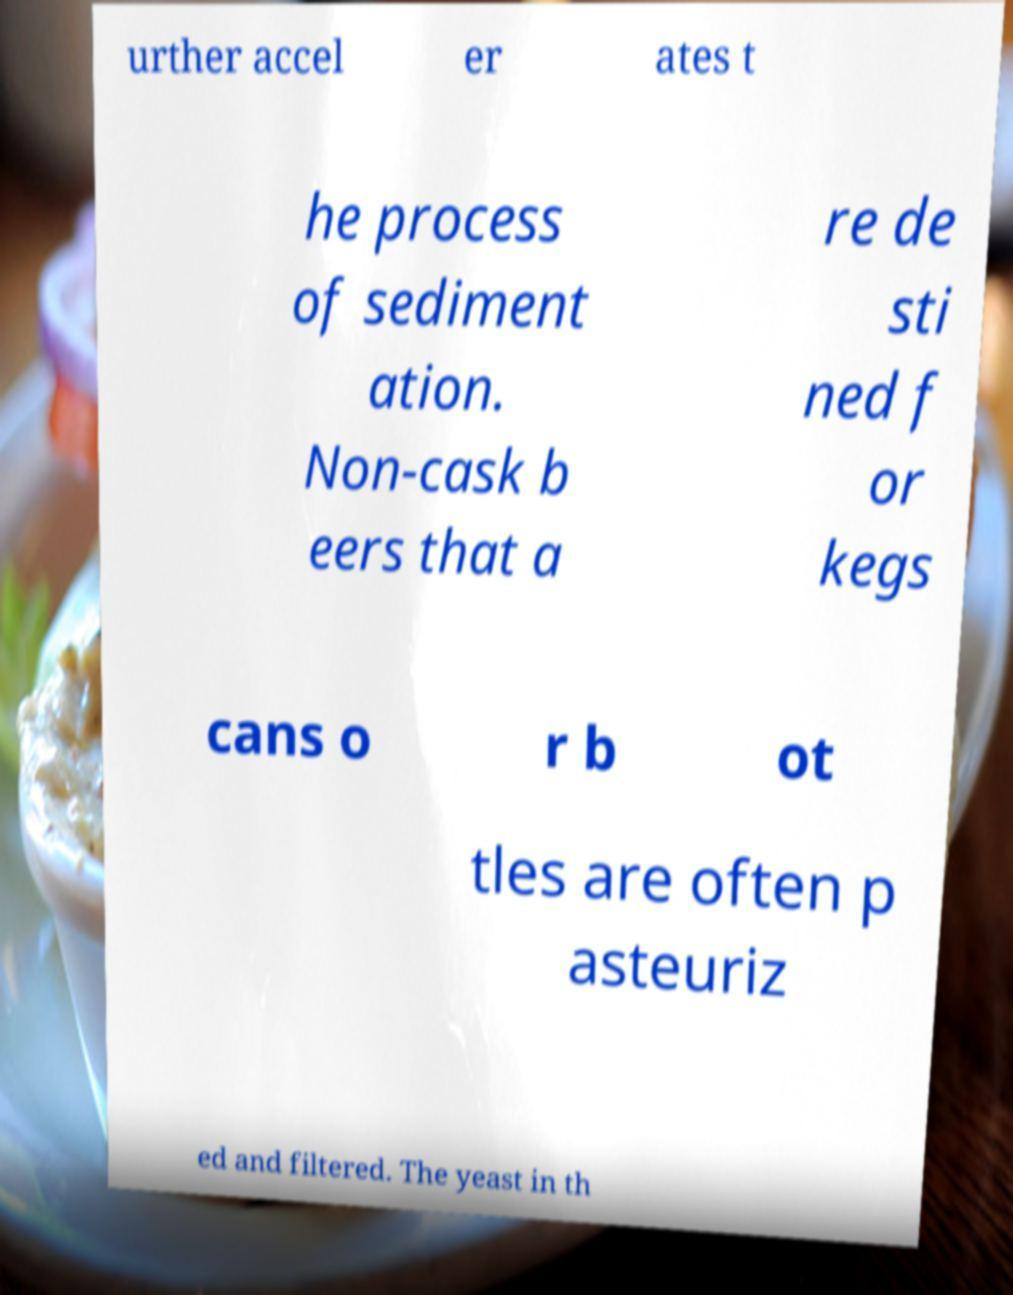There's text embedded in this image that I need extracted. Can you transcribe it verbatim? urther accel er ates t he process of sediment ation. Non-cask b eers that a re de sti ned f or kegs cans o r b ot tles are often p asteuriz ed and filtered. The yeast in th 